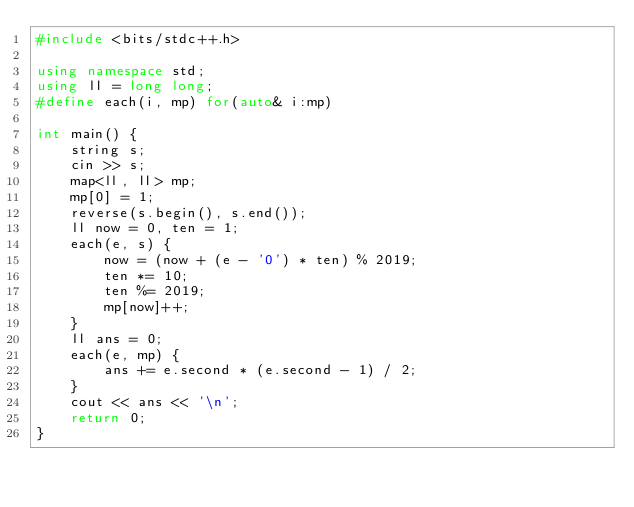<code> <loc_0><loc_0><loc_500><loc_500><_C++_>#include <bits/stdc++.h>

using namespace std;
using ll = long long;
#define each(i, mp) for(auto& i:mp)

int main() {
    string s;
    cin >> s;
    map<ll, ll> mp;
    mp[0] = 1;
    reverse(s.begin(), s.end());
    ll now = 0, ten = 1;
    each(e, s) {
        now = (now + (e - '0') * ten) % 2019;
        ten *= 10;
        ten %= 2019;
        mp[now]++;
    }
    ll ans = 0;
    each(e, mp) {
        ans += e.second * (e.second - 1) / 2;
    }
    cout << ans << '\n';
    return 0;
}</code> 